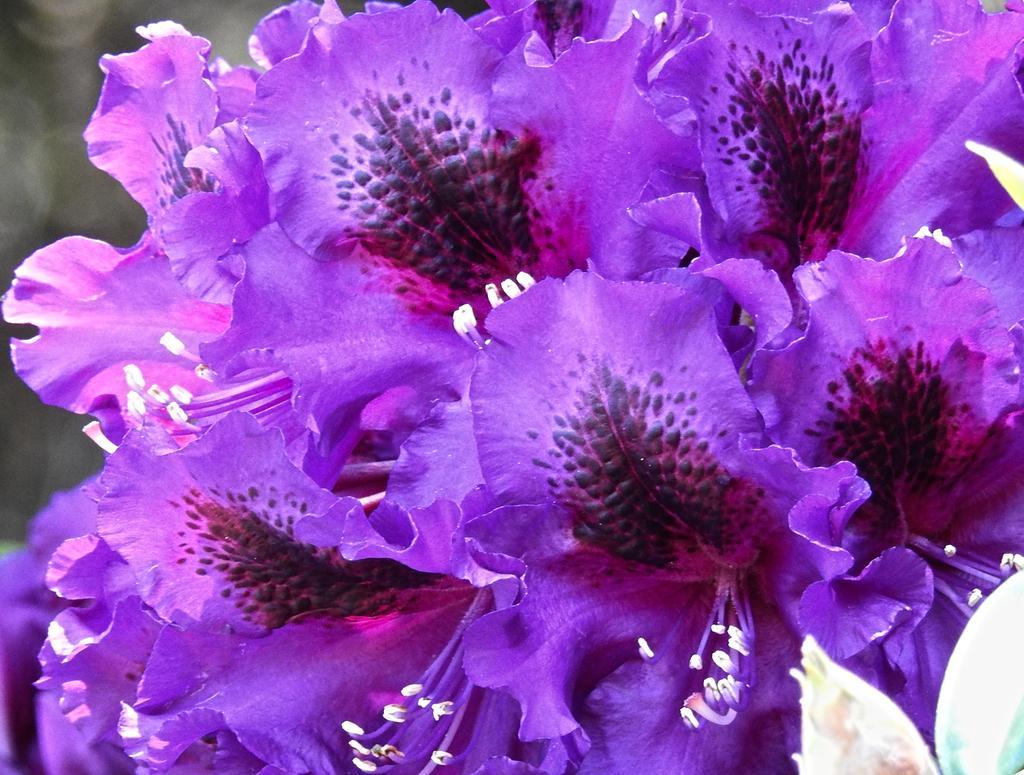Please provide a concise description of this image. In this image we can see the flowers and blur background. 